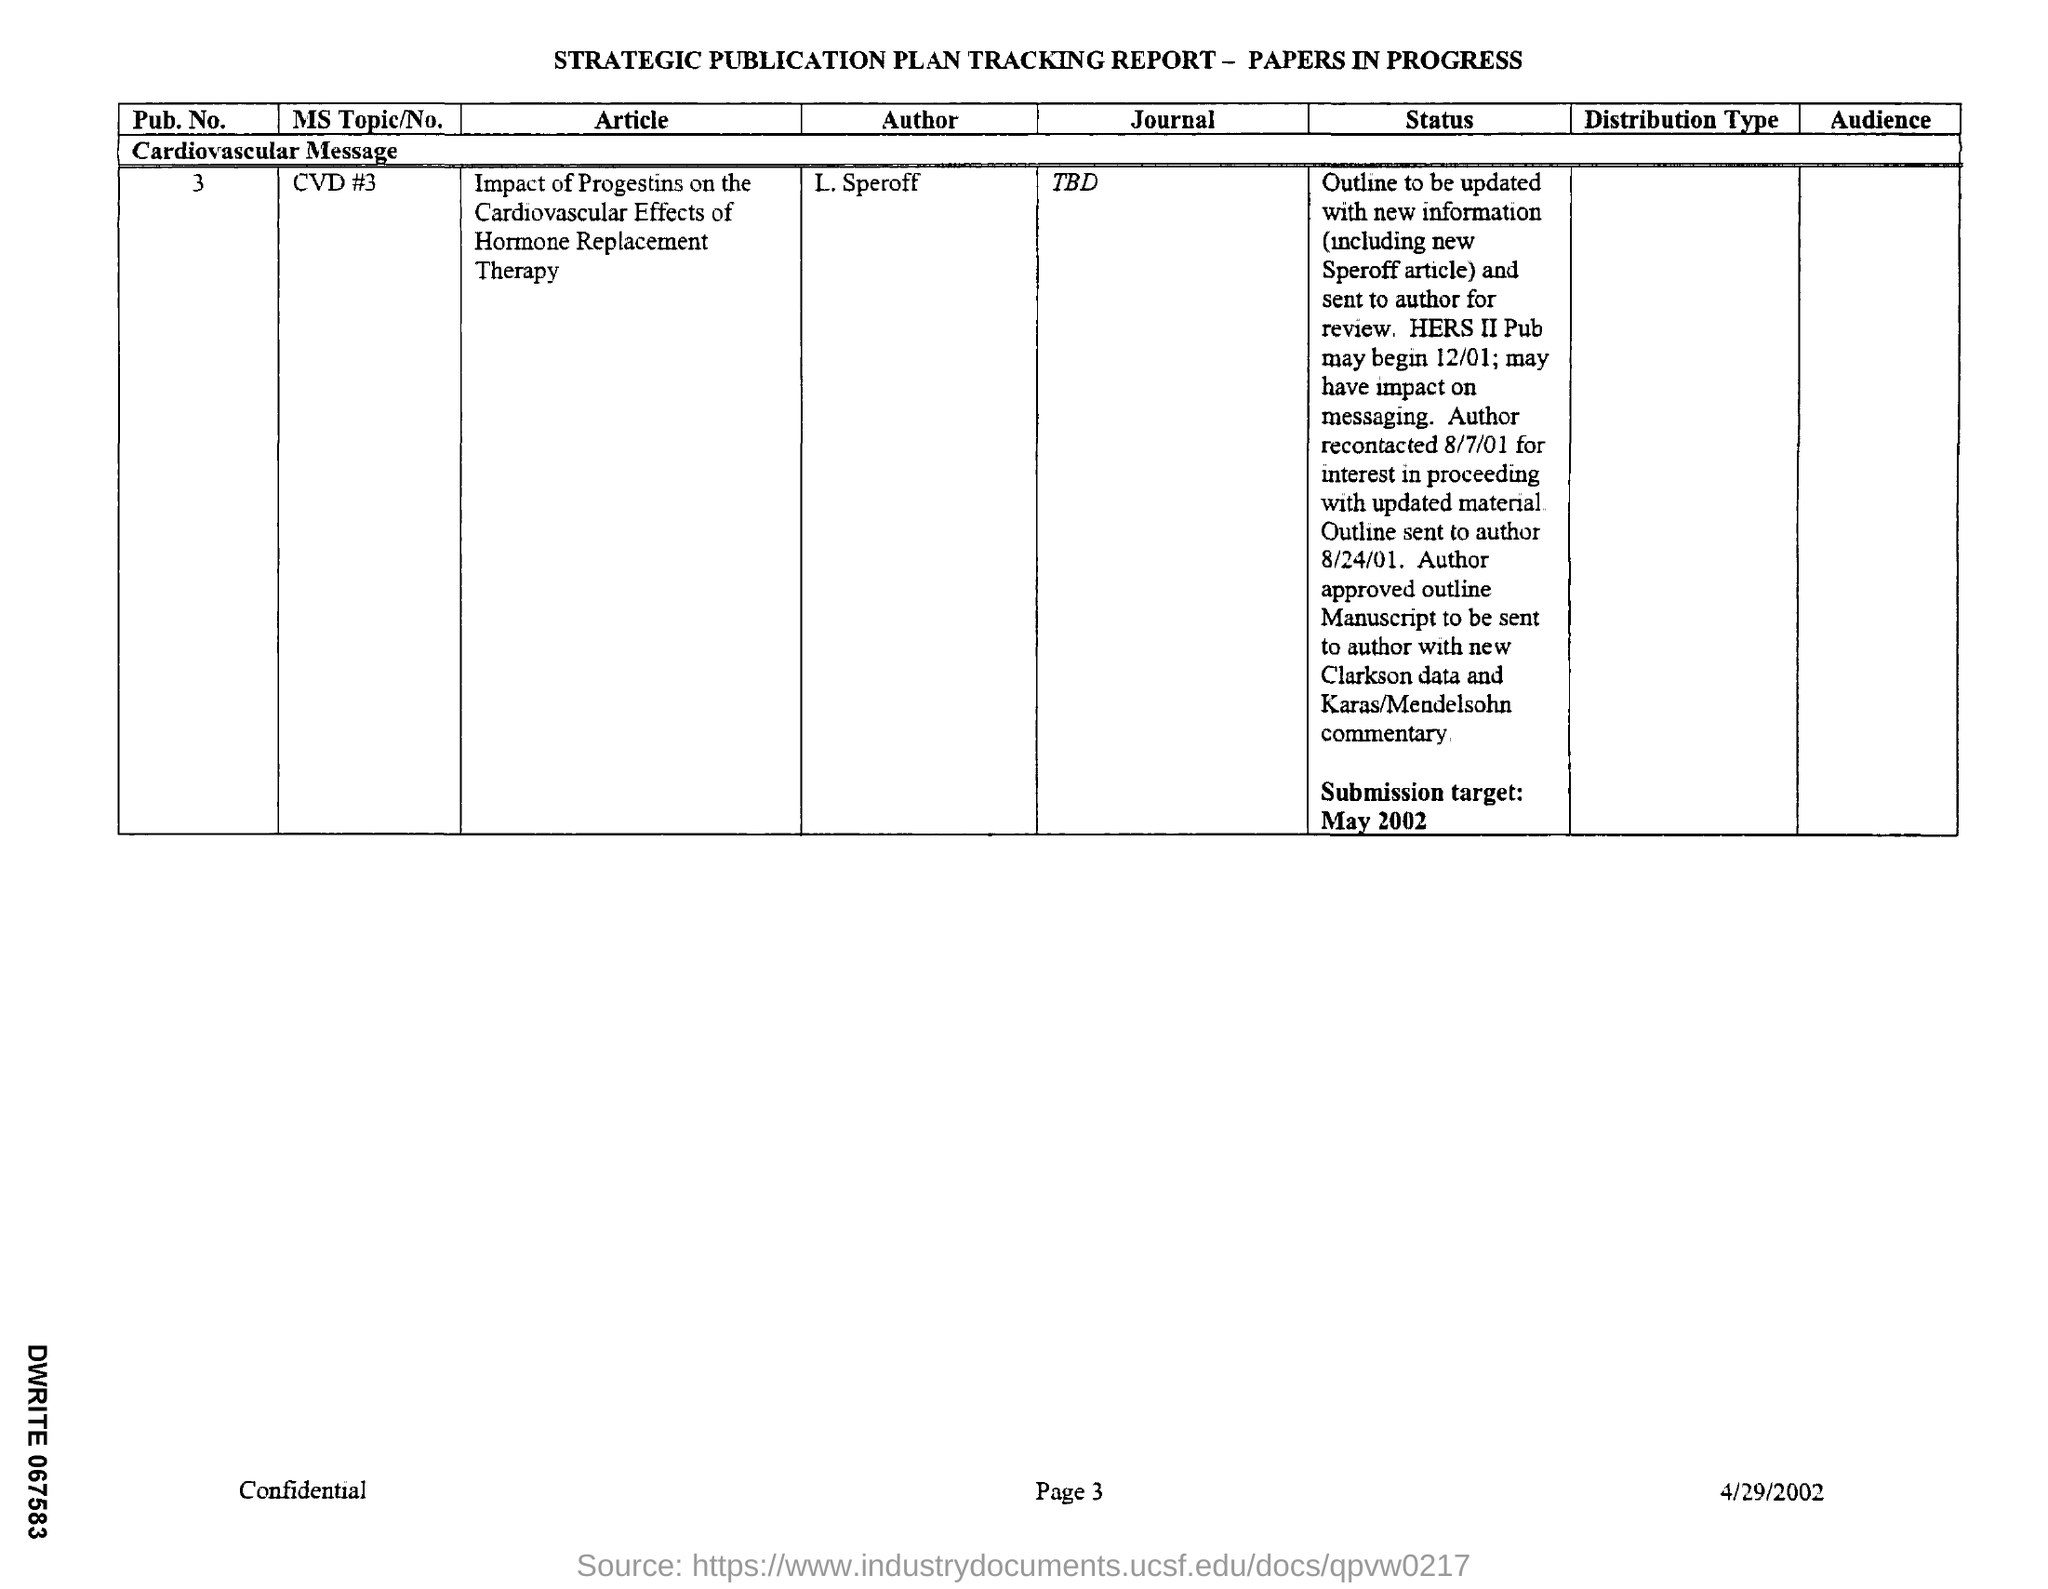What is the article mentioned in the given tracking report ?
Provide a succinct answer. Impact of Progestins on the cardiovascular effects of hormone replacement therapy. What is the pub.no given in the report ?
Keep it short and to the point. 3. What is the date of submission target mentioned in the given report ?
Ensure brevity in your answer.  May 2002. What is the message given in the tracking report ?
Make the answer very short. Cardiovascular message. What is the date mentioned in the tracking report ?
Your response must be concise. 4/29/2002. 